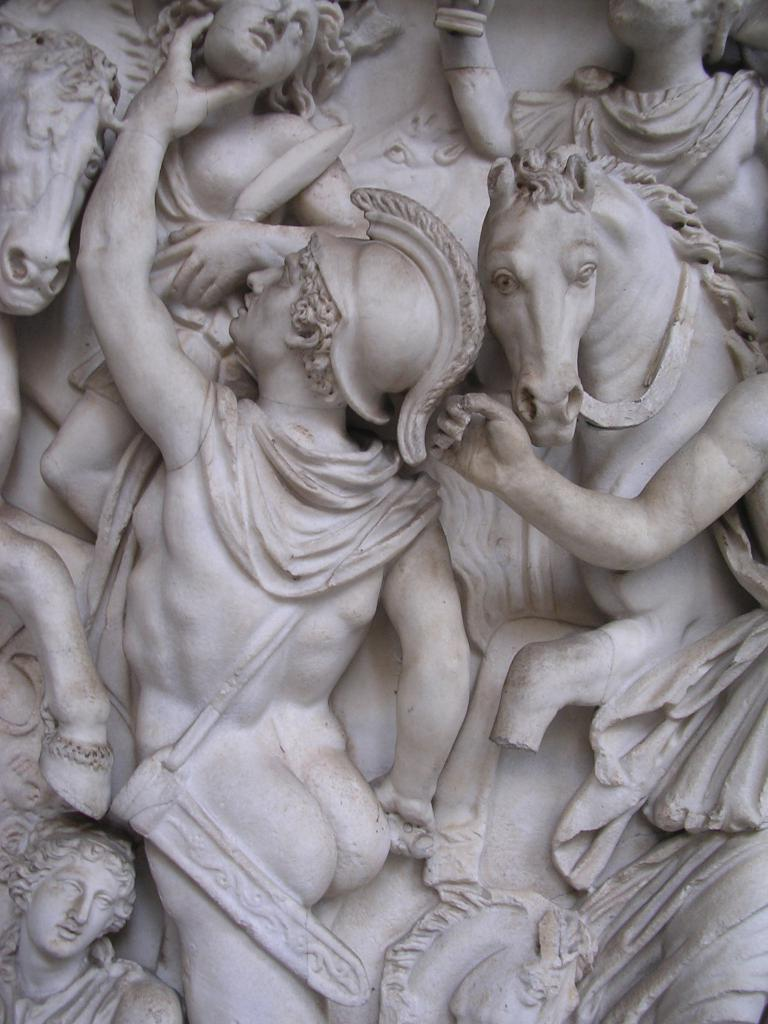What type of sculptures can be seen in the image? There are sculptures of a group of people and horses in the image. Can you describe the subjects of the sculptures? The sculptures depict a group of people and horses. How does the yak join the group of people in the image? There is no yak present in the image, so it cannot join the group of people. 